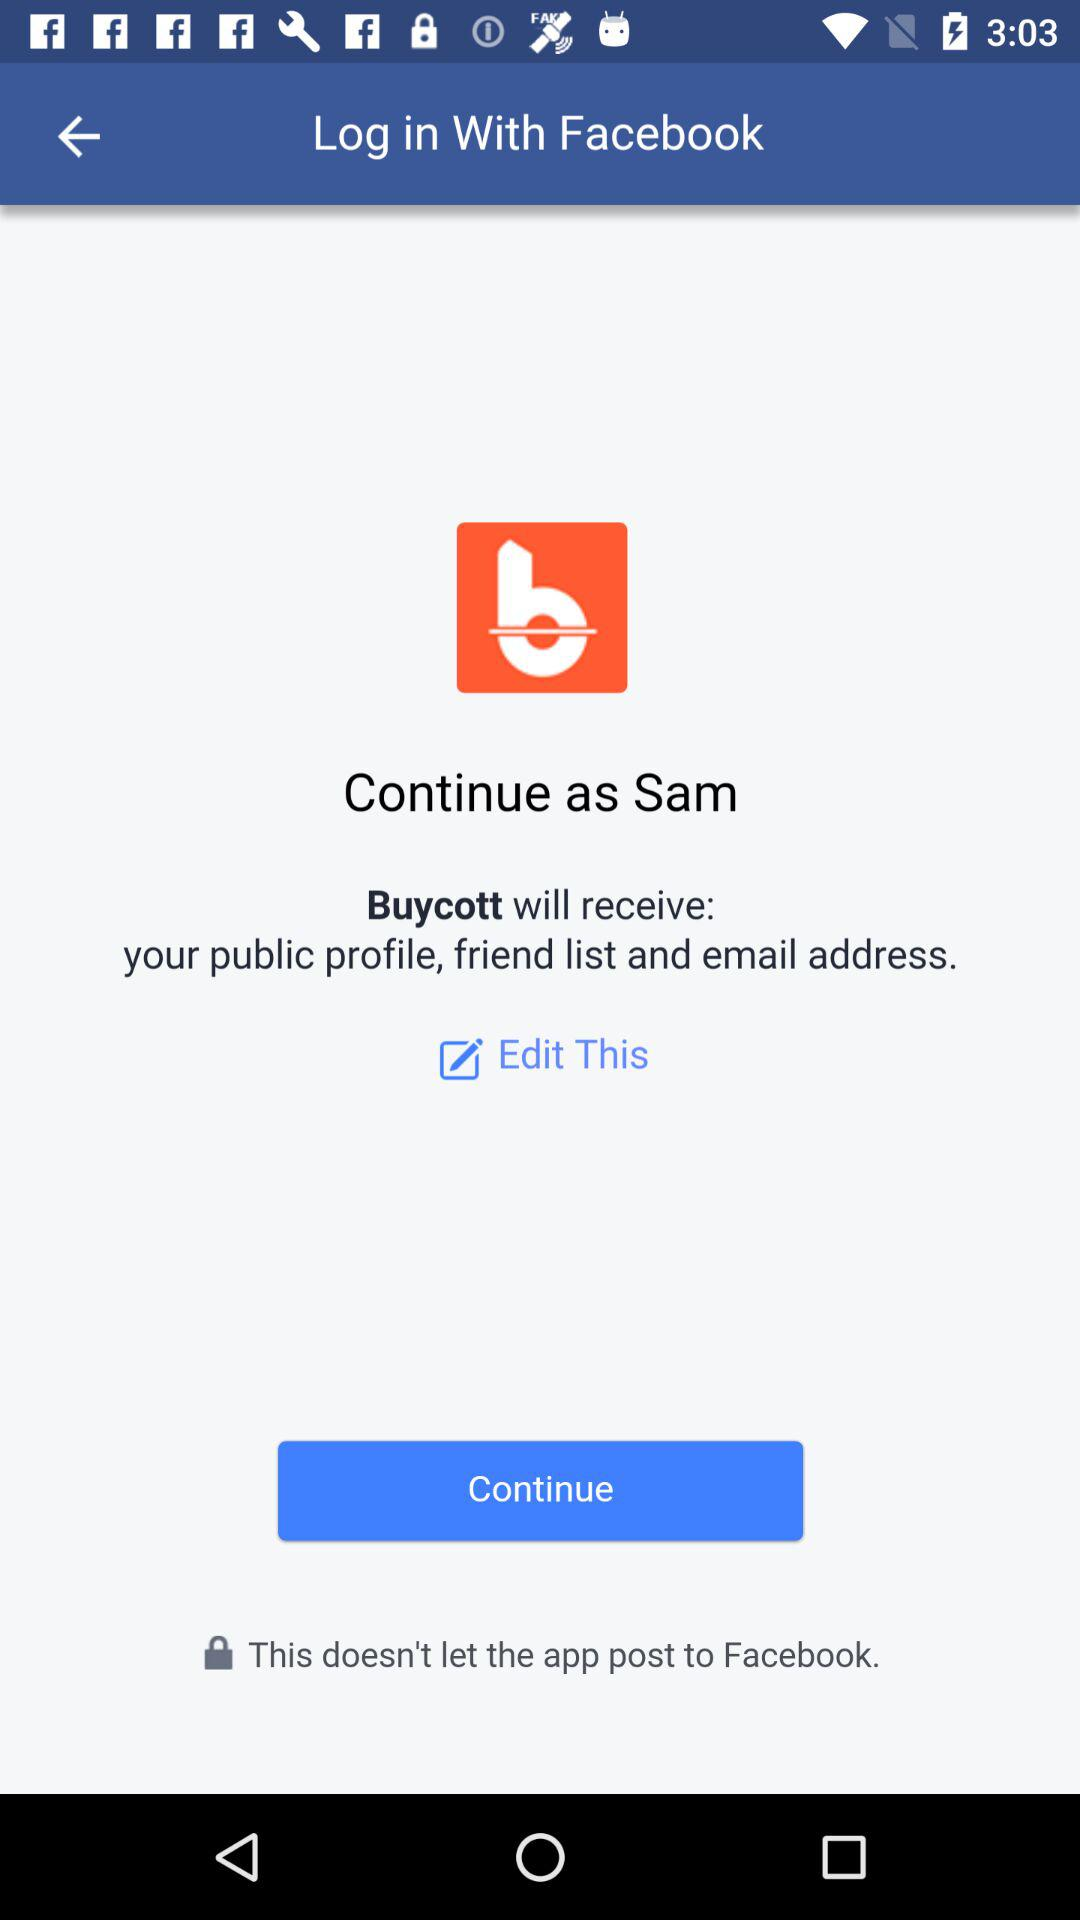What is the profile name? The profile name is Sam. 